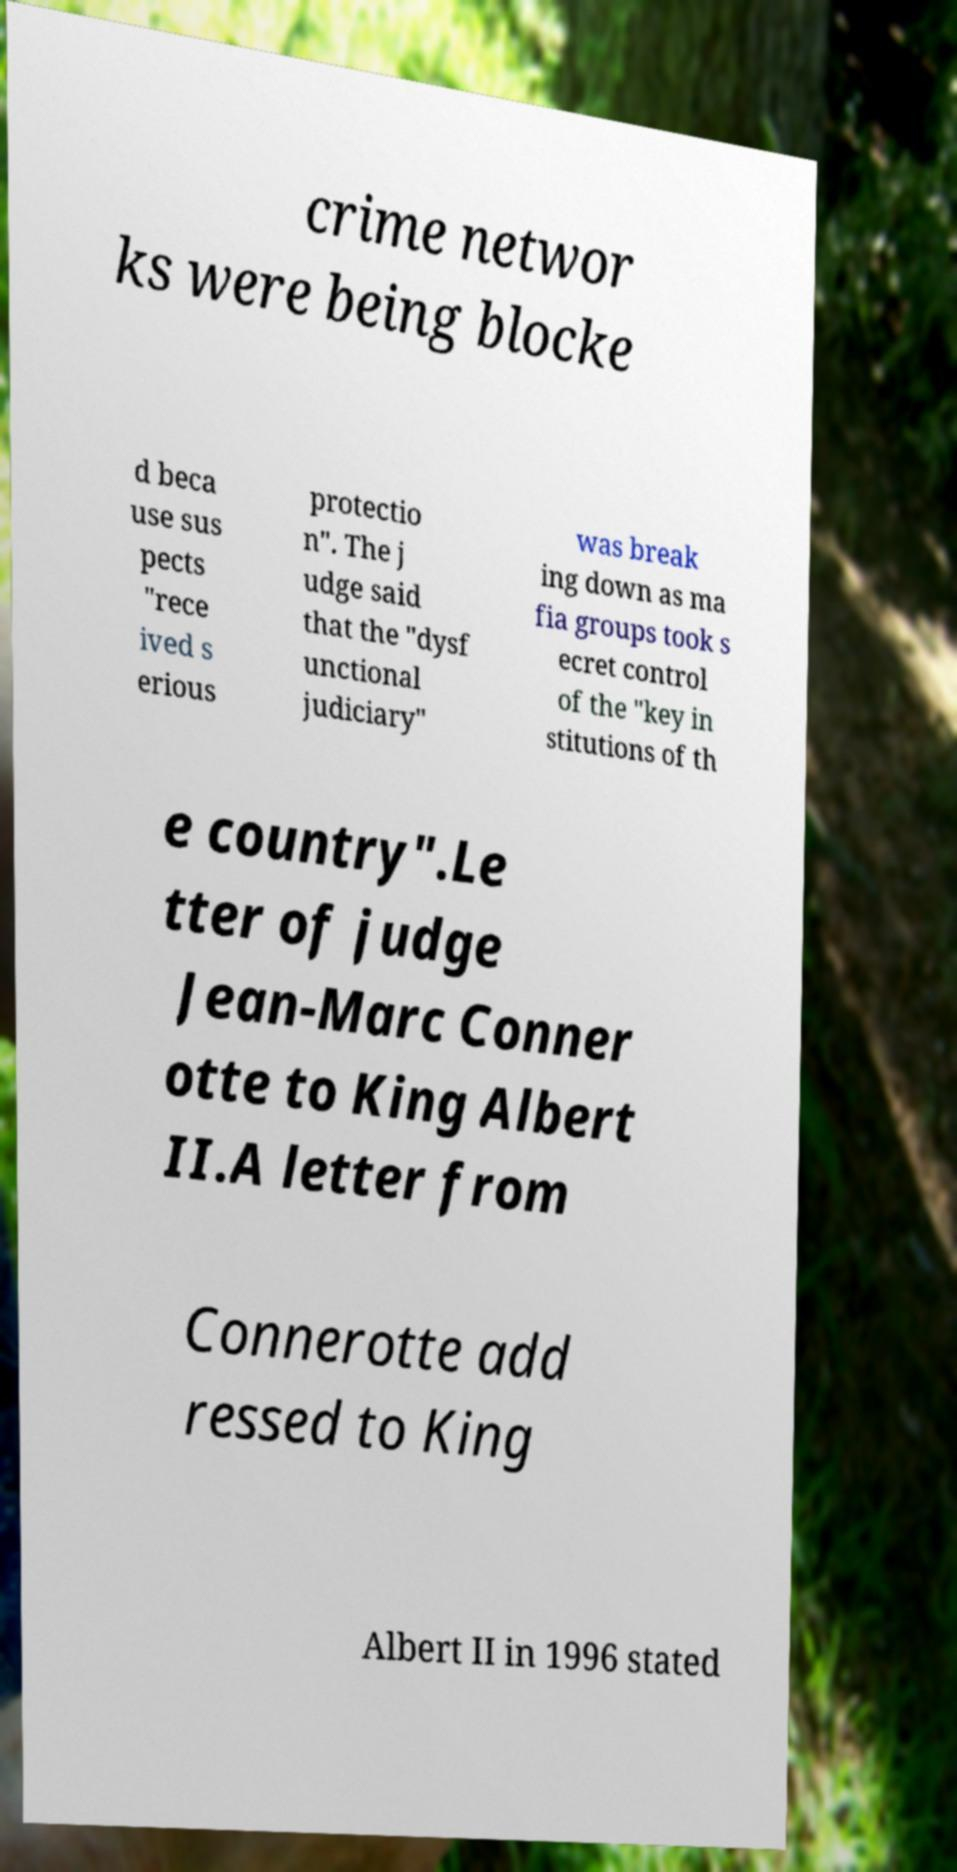What messages or text are displayed in this image? I need them in a readable, typed format. crime networ ks were being blocke d beca use sus pects "rece ived s erious protectio n". The j udge said that the "dysf unctional judiciary" was break ing down as ma fia groups took s ecret control of the "key in stitutions of th e country".Le tter of judge Jean-Marc Conner otte to King Albert II.A letter from Connerotte add ressed to King Albert II in 1996 stated 